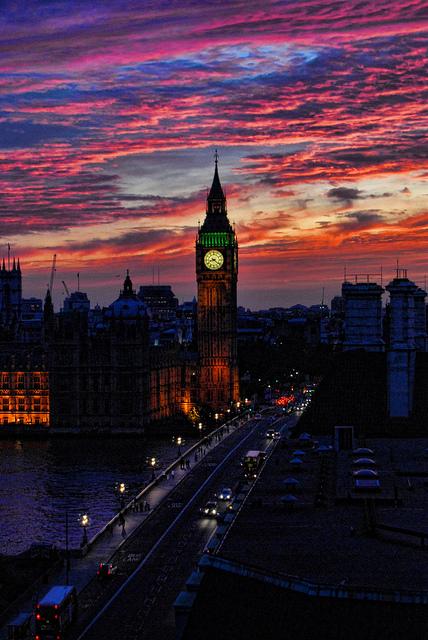What is the sun doing?
Answer briefly. Setting. What time is on the clock?
Short answer required. 8:20. What city is this?
Keep it brief. London. 